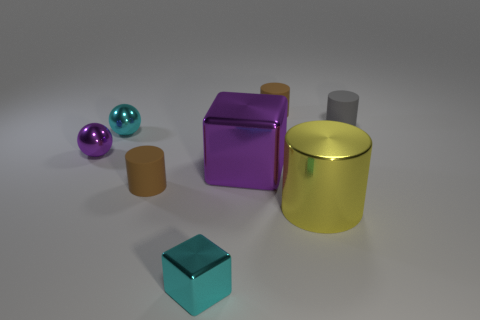Add 2 large spheres. How many objects exist? 10 Subtract all blocks. How many objects are left? 6 Add 3 tiny rubber cylinders. How many tiny rubber cylinders are left? 6 Add 2 large metal cubes. How many large metal cubes exist? 3 Subtract 0 blue cylinders. How many objects are left? 8 Subtract all tiny purple objects. Subtract all tiny shiny blocks. How many objects are left? 6 